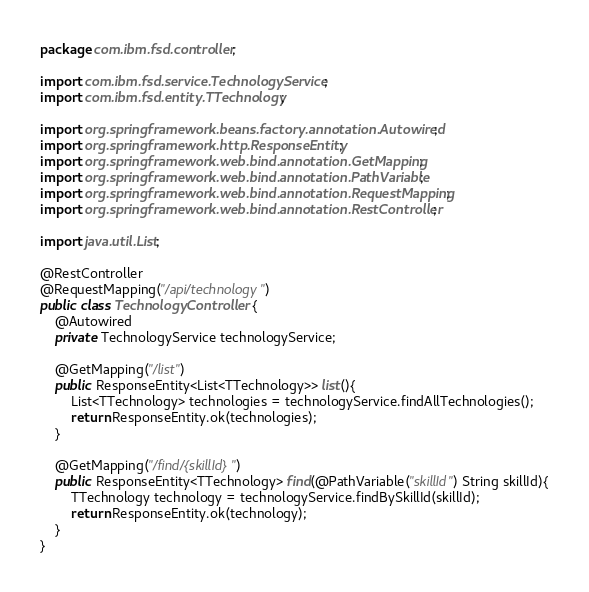Convert code to text. <code><loc_0><loc_0><loc_500><loc_500><_Java_>package com.ibm.fsd.controller;

import com.ibm.fsd.service.TechnologyService;
import com.ibm.fsd.entity.TTechnology;

import org.springframework.beans.factory.annotation.Autowired;
import org.springframework.http.ResponseEntity;
import org.springframework.web.bind.annotation.GetMapping;
import org.springframework.web.bind.annotation.PathVariable;
import org.springframework.web.bind.annotation.RequestMapping;
import org.springframework.web.bind.annotation.RestController;

import java.util.List;

@RestController
@RequestMapping("/api/technology")
public class TechnologyController {
    @Autowired
    private TechnologyService technologyService;

    @GetMapping("/list")
    public ResponseEntity<List<TTechnology>> list(){
        List<TTechnology> technologies = technologyService.findAllTechnologies();
        return ResponseEntity.ok(technologies);
    }

    @GetMapping("/find/{skillId}")
    public ResponseEntity<TTechnology> find(@PathVariable("skillId") String skillId){
        TTechnology technology = technologyService.findBySkillId(skillId);
        return ResponseEntity.ok(technology);
    }
}
</code> 